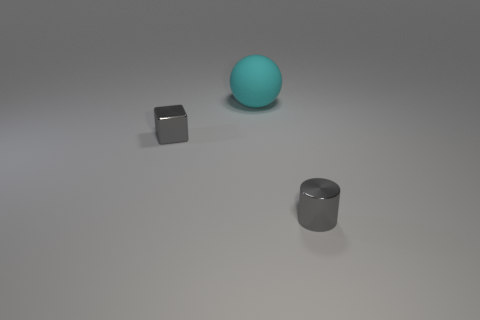Add 3 big brown cubes. How many objects exist? 6 Subtract all cubes. How many objects are left? 2 Subtract all blue balls. How many red cubes are left? 0 Subtract all small metal spheres. Subtract all gray objects. How many objects are left? 1 Add 2 small blocks. How many small blocks are left? 3 Add 2 cyan rubber cylinders. How many cyan rubber cylinders exist? 2 Subtract 0 blue spheres. How many objects are left? 3 Subtract all red cylinders. Subtract all cyan balls. How many cylinders are left? 1 